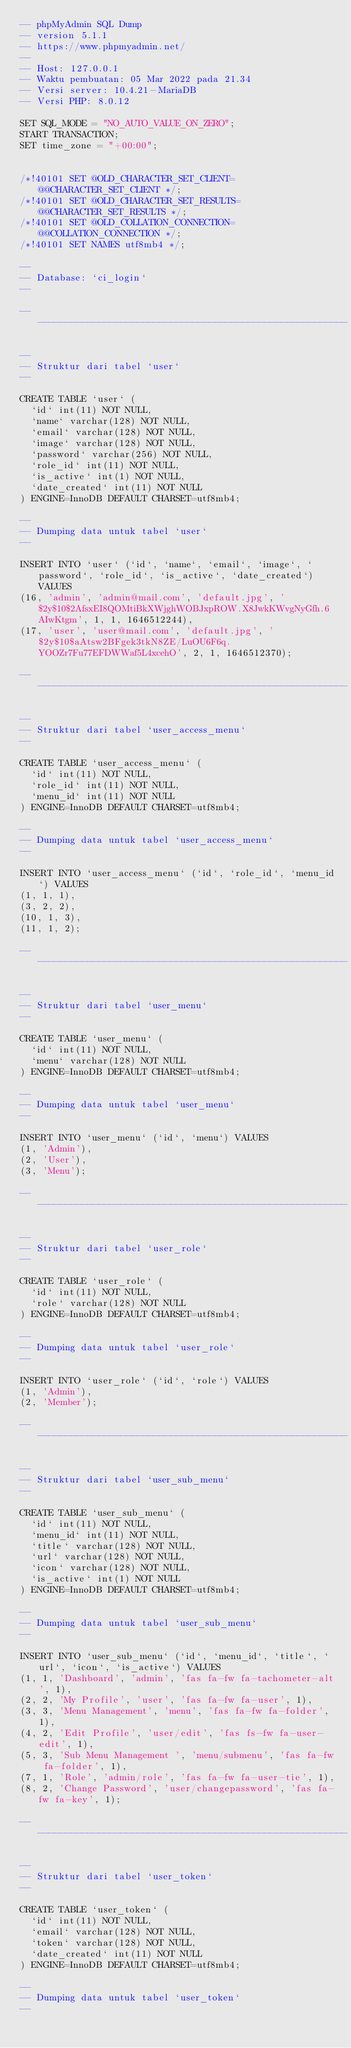<code> <loc_0><loc_0><loc_500><loc_500><_SQL_>-- phpMyAdmin SQL Dump
-- version 5.1.1
-- https://www.phpmyadmin.net/
--
-- Host: 127.0.0.1
-- Waktu pembuatan: 05 Mar 2022 pada 21.34
-- Versi server: 10.4.21-MariaDB
-- Versi PHP: 8.0.12

SET SQL_MODE = "NO_AUTO_VALUE_ON_ZERO";
START TRANSACTION;
SET time_zone = "+00:00";


/*!40101 SET @OLD_CHARACTER_SET_CLIENT=@@CHARACTER_SET_CLIENT */;
/*!40101 SET @OLD_CHARACTER_SET_RESULTS=@@CHARACTER_SET_RESULTS */;
/*!40101 SET @OLD_COLLATION_CONNECTION=@@COLLATION_CONNECTION */;
/*!40101 SET NAMES utf8mb4 */;

--
-- Database: `ci_login`
--

-- --------------------------------------------------------

--
-- Struktur dari tabel `user`
--

CREATE TABLE `user` (
  `id` int(11) NOT NULL,
  `name` varchar(128) NOT NULL,
  `email` varchar(128) NOT NULL,
  `image` varchar(128) NOT NULL,
  `password` varchar(256) NOT NULL,
  `role_id` int(11) NOT NULL,
  `is_active` int(1) NOT NULL,
  `date_created` int(11) NOT NULL
) ENGINE=InnoDB DEFAULT CHARSET=utf8mb4;

--
-- Dumping data untuk tabel `user`
--

INSERT INTO `user` (`id`, `name`, `email`, `image`, `password`, `role_id`, `is_active`, `date_created`) VALUES
(16, 'admin', 'admin@mail.com', 'default.jpg', '$2y$10$2AfsxEI8QOMtiBkXWjghWOBJxpROW.X8JwkKWvgNyGfh.6AIwKtgm', 1, 1, 1646512244),
(17, 'user', 'user@mail.com', 'default.jpg', '$2y$10$aAtsw2BFgek3tkN8ZE/LuOU6F6q.YOOZr7Fu77EFDWWaf5L4xcehO', 2, 1, 1646512370);

-- --------------------------------------------------------

--
-- Struktur dari tabel `user_access_menu`
--

CREATE TABLE `user_access_menu` (
  `id` int(11) NOT NULL,
  `role_id` int(11) NOT NULL,
  `menu_id` int(11) NOT NULL
) ENGINE=InnoDB DEFAULT CHARSET=utf8mb4;

--
-- Dumping data untuk tabel `user_access_menu`
--

INSERT INTO `user_access_menu` (`id`, `role_id`, `menu_id`) VALUES
(1, 1, 1),
(3, 2, 2),
(10, 1, 3),
(11, 1, 2);

-- --------------------------------------------------------

--
-- Struktur dari tabel `user_menu`
--

CREATE TABLE `user_menu` (
  `id` int(11) NOT NULL,
  `menu` varchar(128) NOT NULL
) ENGINE=InnoDB DEFAULT CHARSET=utf8mb4;

--
-- Dumping data untuk tabel `user_menu`
--

INSERT INTO `user_menu` (`id`, `menu`) VALUES
(1, 'Admin'),
(2, 'User'),
(3, 'Menu');

-- --------------------------------------------------------

--
-- Struktur dari tabel `user_role`
--

CREATE TABLE `user_role` (
  `id` int(11) NOT NULL,
  `role` varchar(128) NOT NULL
) ENGINE=InnoDB DEFAULT CHARSET=utf8mb4;

--
-- Dumping data untuk tabel `user_role`
--

INSERT INTO `user_role` (`id`, `role`) VALUES
(1, 'Admin'),
(2, 'Member');

-- --------------------------------------------------------

--
-- Struktur dari tabel `user_sub_menu`
--

CREATE TABLE `user_sub_menu` (
  `id` int(11) NOT NULL,
  `menu_id` int(11) NOT NULL,
  `title` varchar(128) NOT NULL,
  `url` varchar(128) NOT NULL,
  `icon` varchar(128) NOT NULL,
  `is_active` int(1) NOT NULL
) ENGINE=InnoDB DEFAULT CHARSET=utf8mb4;

--
-- Dumping data untuk tabel `user_sub_menu`
--

INSERT INTO `user_sub_menu` (`id`, `menu_id`, `title`, `url`, `icon`, `is_active`) VALUES
(1, 1, 'Dashboard', 'admin', 'fas fa-fw fa-tachometer-alt', 1),
(2, 2, 'My Profile', 'user', 'fas fa-fw fa-user', 1),
(3, 3, 'Menu Management', 'menu', 'fas fa-fw fa-folder', 1),
(4, 2, 'Edit Profile', 'user/edit', 'fas fs-fw fa-user-edit', 1),
(5, 3, 'Sub Menu Management ', 'menu/submenu', 'fas fa-fw fa-folder', 1),
(7, 1, 'Role', 'admin/role', 'fas fa-fw fa-user-tie', 1),
(8, 2, 'Change Password', 'user/changepassword', 'fas fa-fw fa-key', 1);

-- --------------------------------------------------------

--
-- Struktur dari tabel `user_token`
--

CREATE TABLE `user_token` (
  `id` int(11) NOT NULL,
  `email` varchar(128) NOT NULL,
  `token` varchar(128) NOT NULL,
  `date_created` int(11) NOT NULL
) ENGINE=InnoDB DEFAULT CHARSET=utf8mb4;

--
-- Dumping data untuk tabel `user_token`
--
</code> 